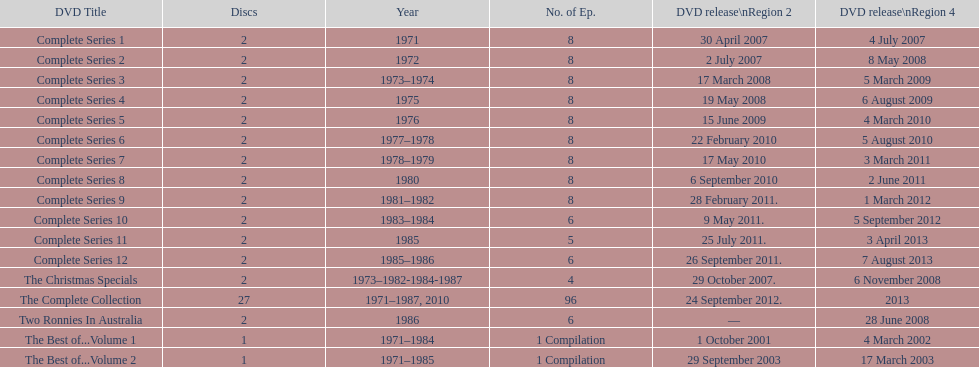What comes next after the complete set of series 11? Complete Series 12. 